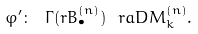Convert formula to latex. <formula><loc_0><loc_0><loc_500><loc_500>\varphi ^ { \prime } \colon \ \Gamma ( r B ^ { ( n ) } _ { \bullet } ) \ r a D M ^ { ( n ) } _ { k } .</formula> 